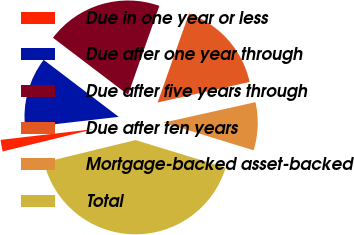<chart> <loc_0><loc_0><loc_500><loc_500><pie_chart><fcel>Due in one year or less<fcel>Due after one year through<fcel>Due after five years through<fcel>Due after ten years<fcel>Mortgage-backed asset-backed<fcel>Total<nl><fcel>1.99%<fcel>12.16%<fcel>20.06%<fcel>16.11%<fcel>8.22%<fcel>41.46%<nl></chart> 